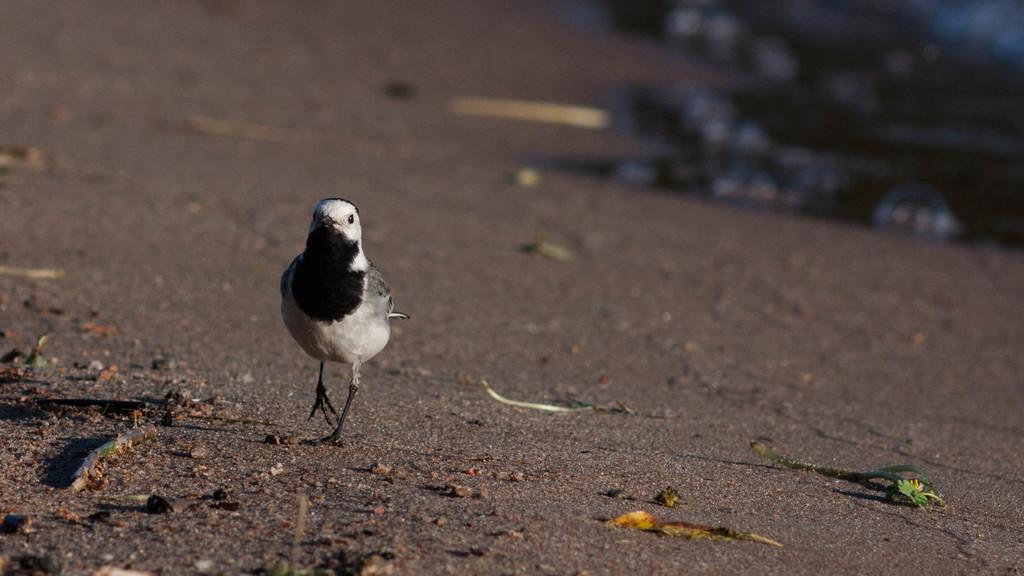Describe this image in one or two sentences. On the left side, there is a bird with black and white color combination, walking on the road. On which there are sticks, leaves and stones. And the background is blurred. 